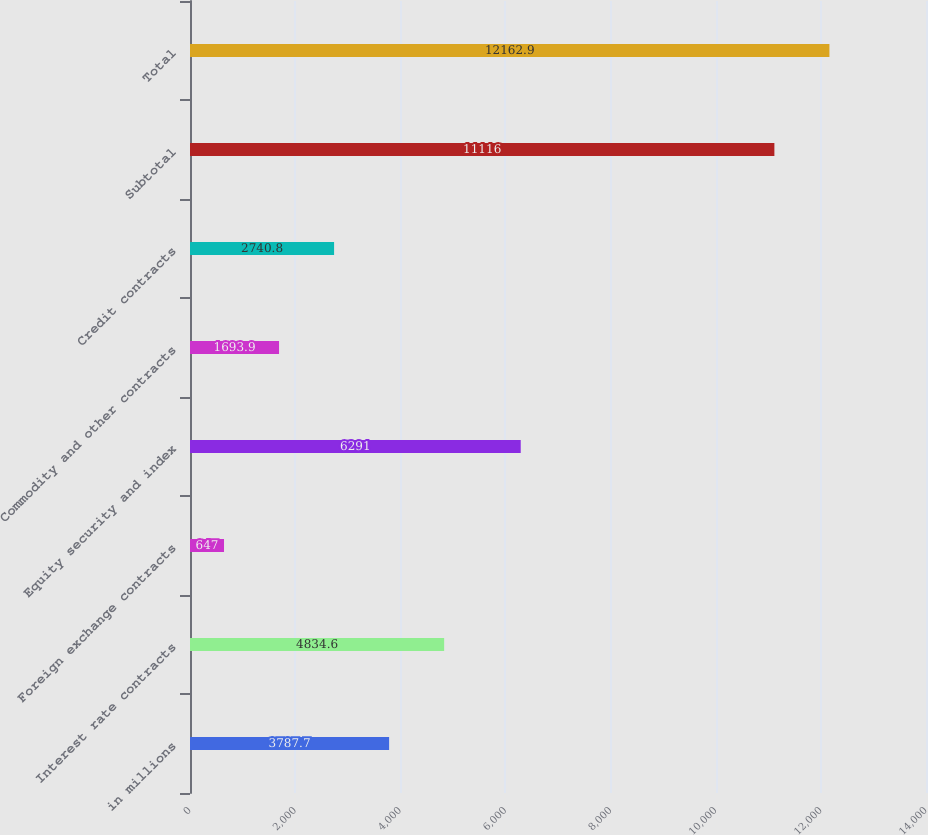Convert chart. <chart><loc_0><loc_0><loc_500><loc_500><bar_chart><fcel>in millions<fcel>Interest rate contracts<fcel>Foreign exchange contracts<fcel>Equity security and index<fcel>Commodity and other contracts<fcel>Credit contracts<fcel>Subtotal<fcel>Total<nl><fcel>3787.7<fcel>4834.6<fcel>647<fcel>6291<fcel>1693.9<fcel>2740.8<fcel>11116<fcel>12162.9<nl></chart> 